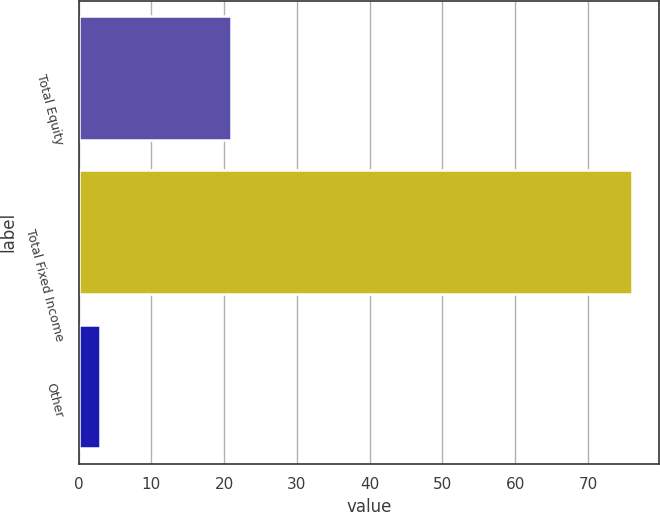Convert chart to OTSL. <chart><loc_0><loc_0><loc_500><loc_500><bar_chart><fcel>Total Equity<fcel>Total Fixed Income<fcel>Other<nl><fcel>21<fcel>76<fcel>3<nl></chart> 